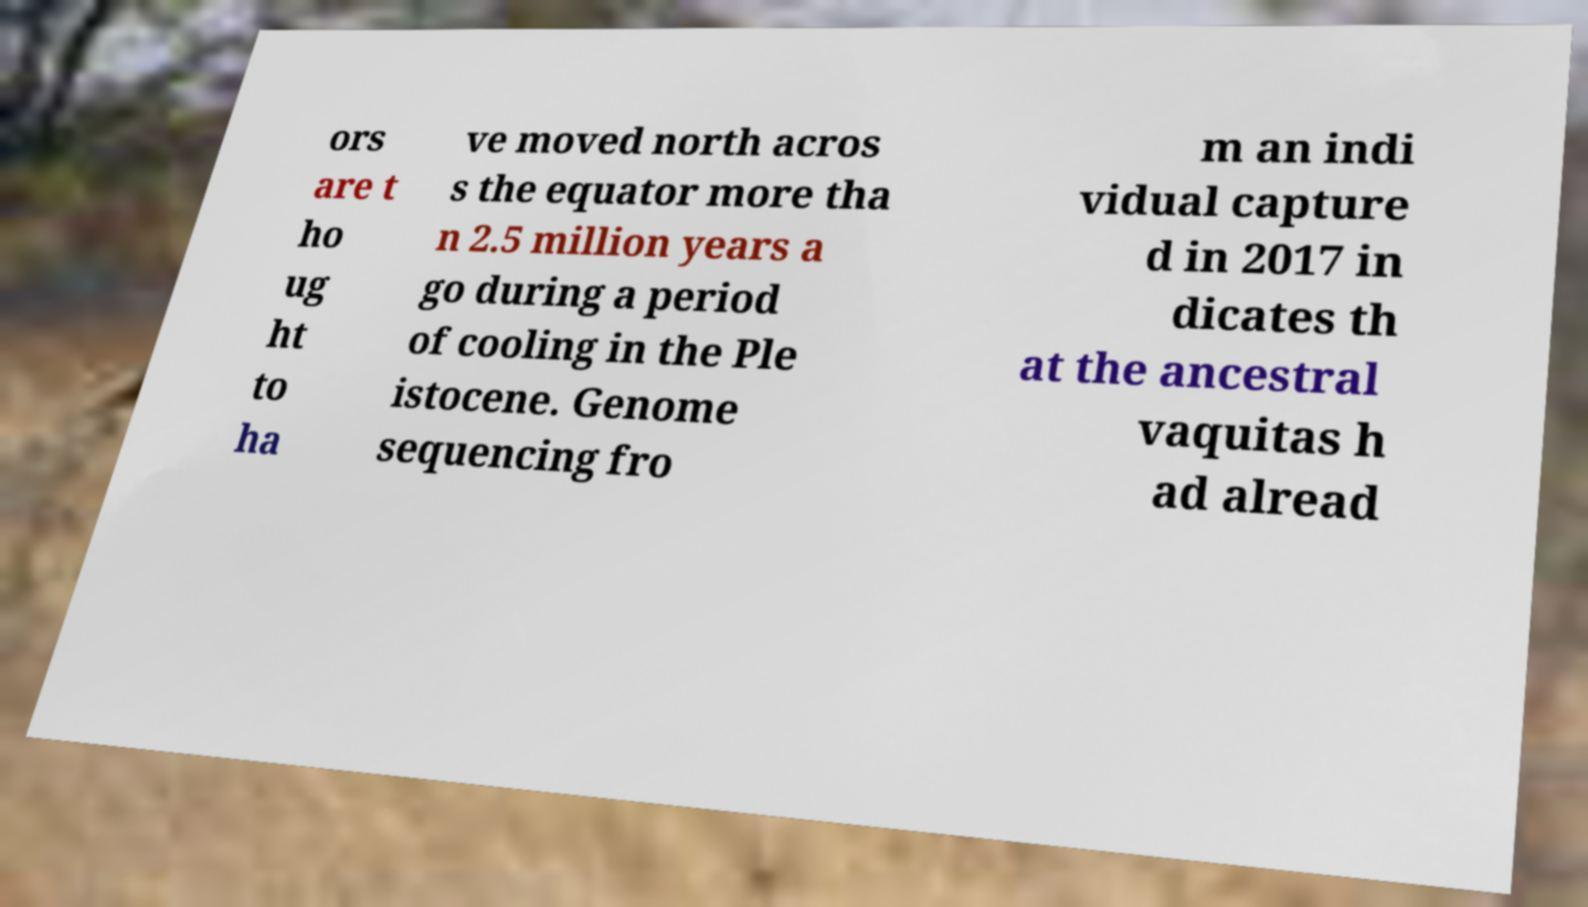Can you accurately transcribe the text from the provided image for me? ors are t ho ug ht to ha ve moved north acros s the equator more tha n 2.5 million years a go during a period of cooling in the Ple istocene. Genome sequencing fro m an indi vidual capture d in 2017 in dicates th at the ancestral vaquitas h ad alread 